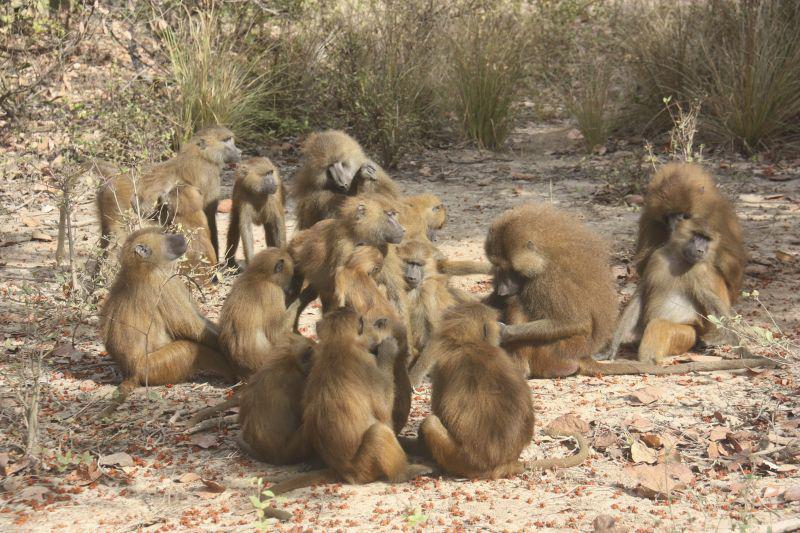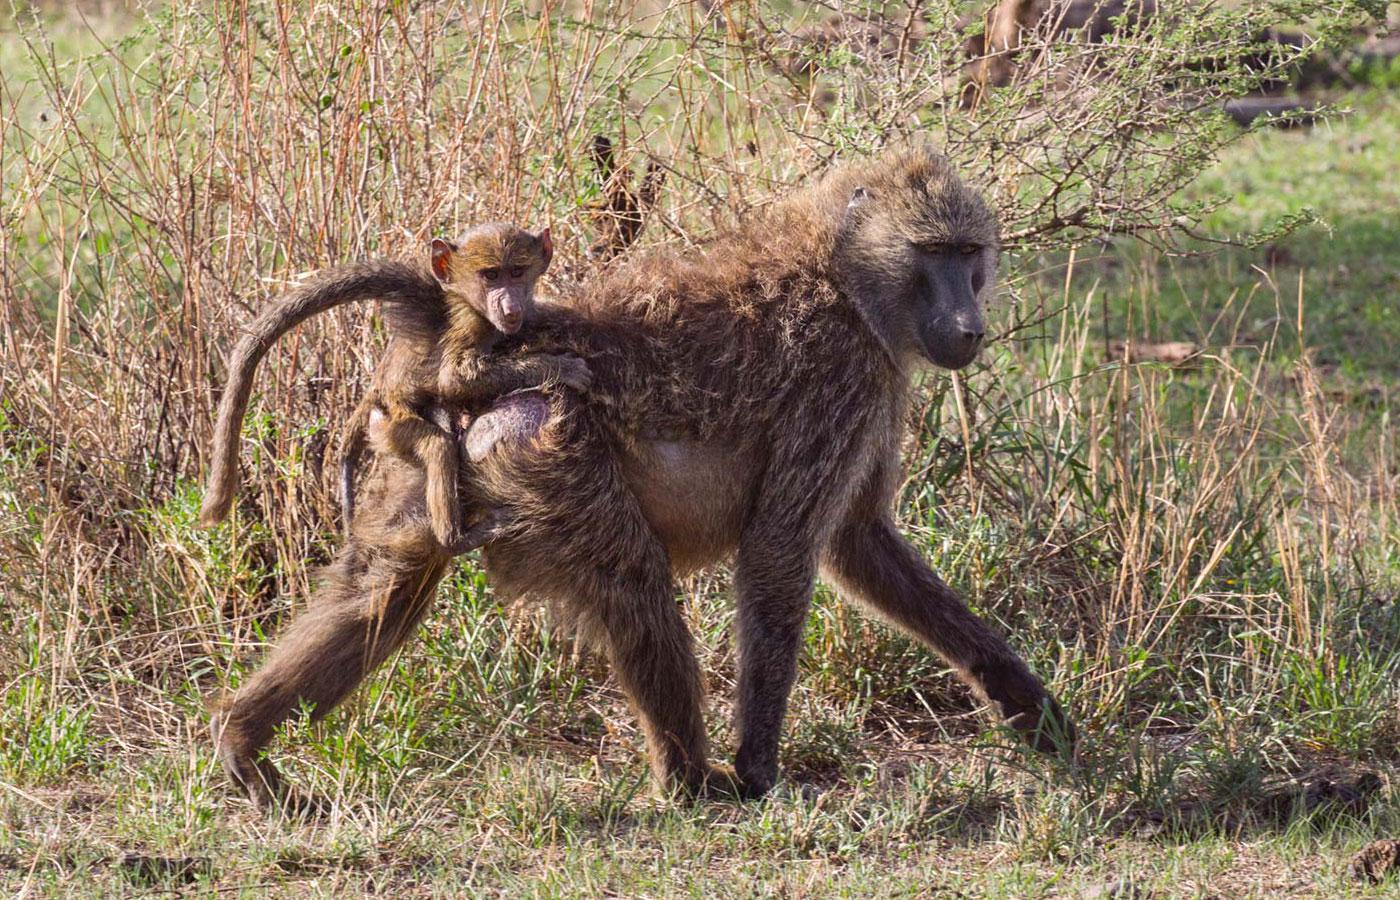The first image is the image on the left, the second image is the image on the right. Assess this claim about the two images: "The combined images contain six baboons.". Correct or not? Answer yes or no. No. The first image is the image on the left, the second image is the image on the right. Given the left and right images, does the statement "The left image contains no more than two monkeys." hold true? Answer yes or no. No. 